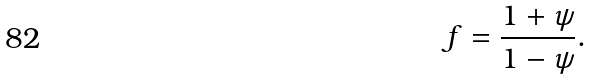Convert formula to latex. <formula><loc_0><loc_0><loc_500><loc_500>f = \frac { 1 + \psi } { 1 - \psi } .</formula> 